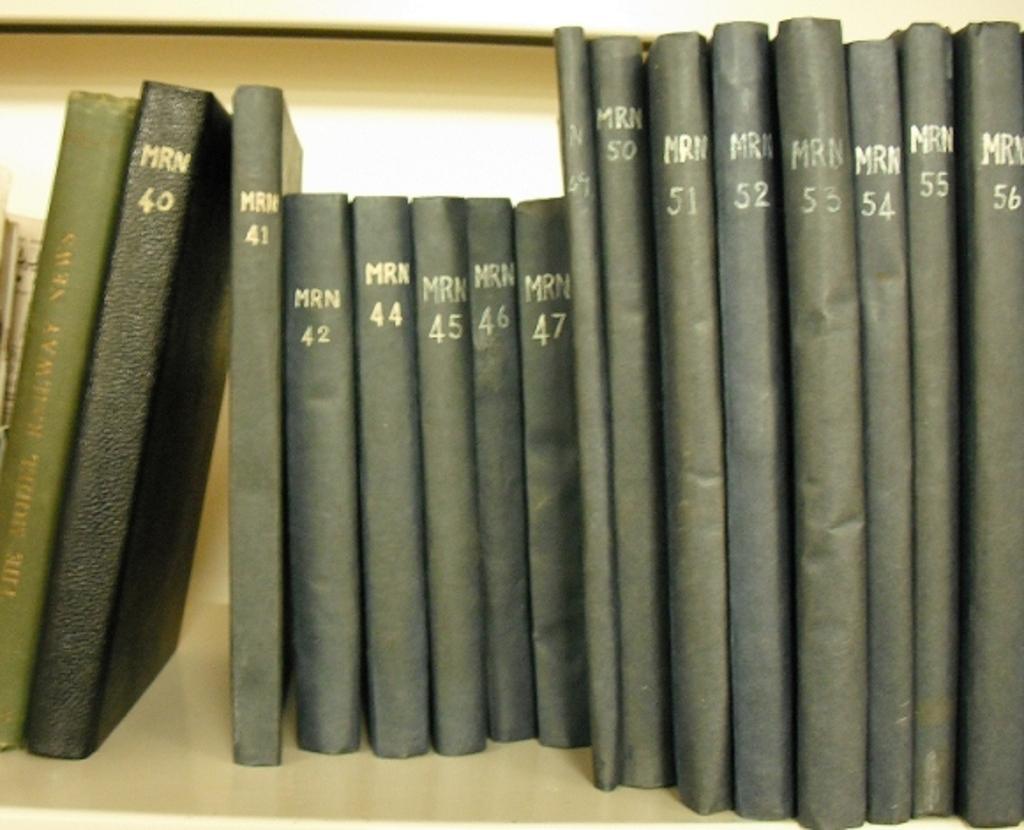Describe this image in one or two sentences. In this image we can see a few books on the bookshelf. 